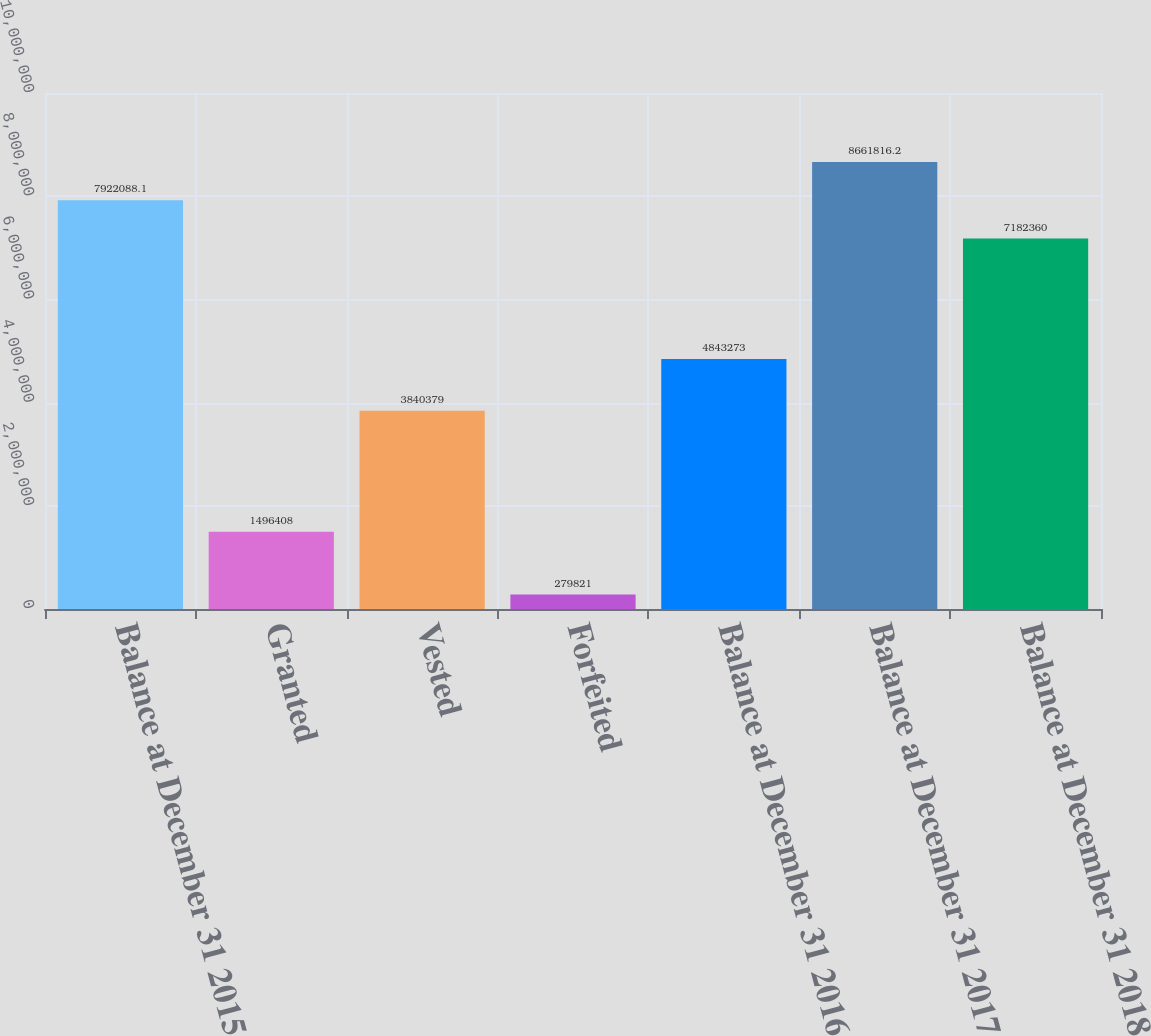Convert chart to OTSL. <chart><loc_0><loc_0><loc_500><loc_500><bar_chart><fcel>Balance at December 31 2015<fcel>Granted<fcel>Vested<fcel>Forfeited<fcel>Balance at December 31 2016<fcel>Balance at December 31 2017<fcel>Balance at December 31 2018<nl><fcel>7.92209e+06<fcel>1.49641e+06<fcel>3.84038e+06<fcel>279821<fcel>4.84327e+06<fcel>8.66182e+06<fcel>7.18236e+06<nl></chart> 